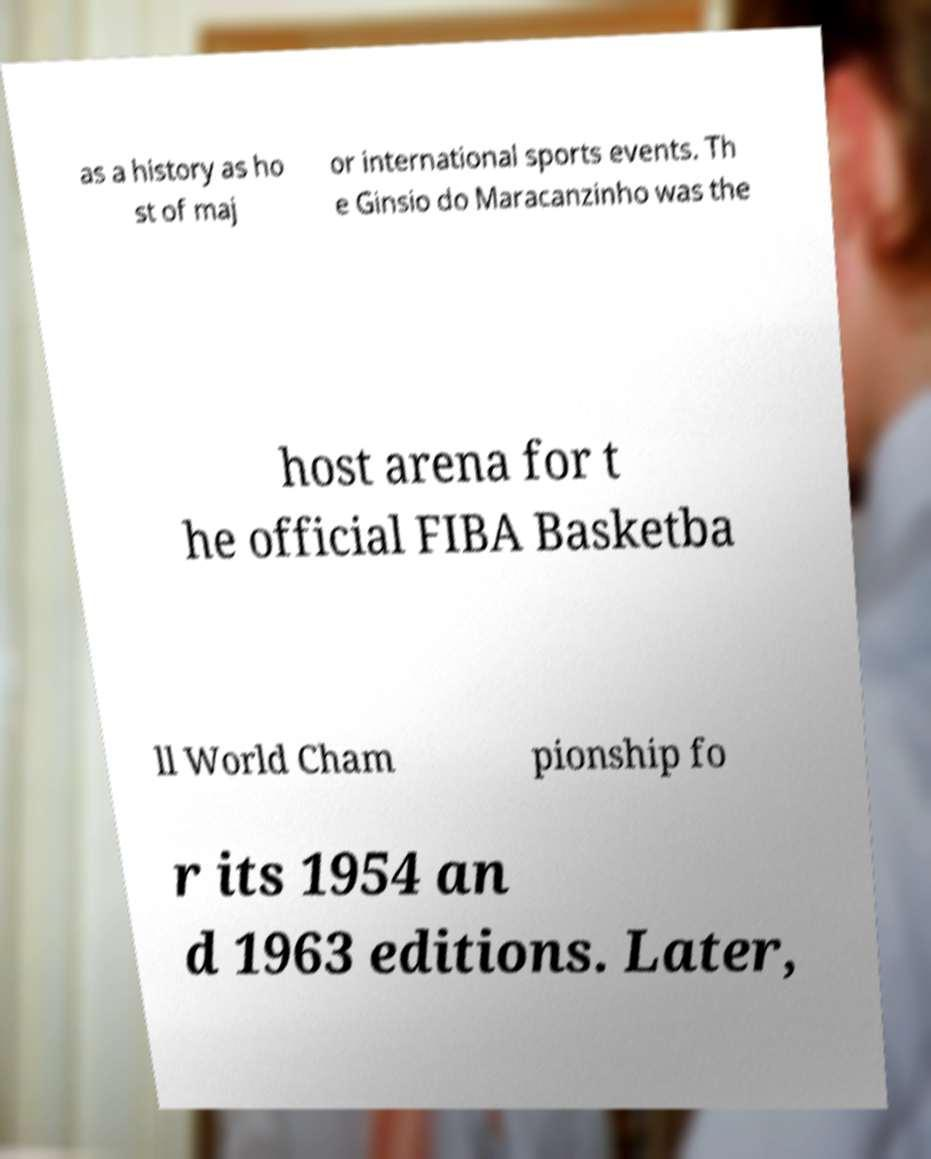For documentation purposes, I need the text within this image transcribed. Could you provide that? as a history as ho st of maj or international sports events. Th e Ginsio do Maracanzinho was the host arena for t he official FIBA Basketba ll World Cham pionship fo r its 1954 an d 1963 editions. Later, 